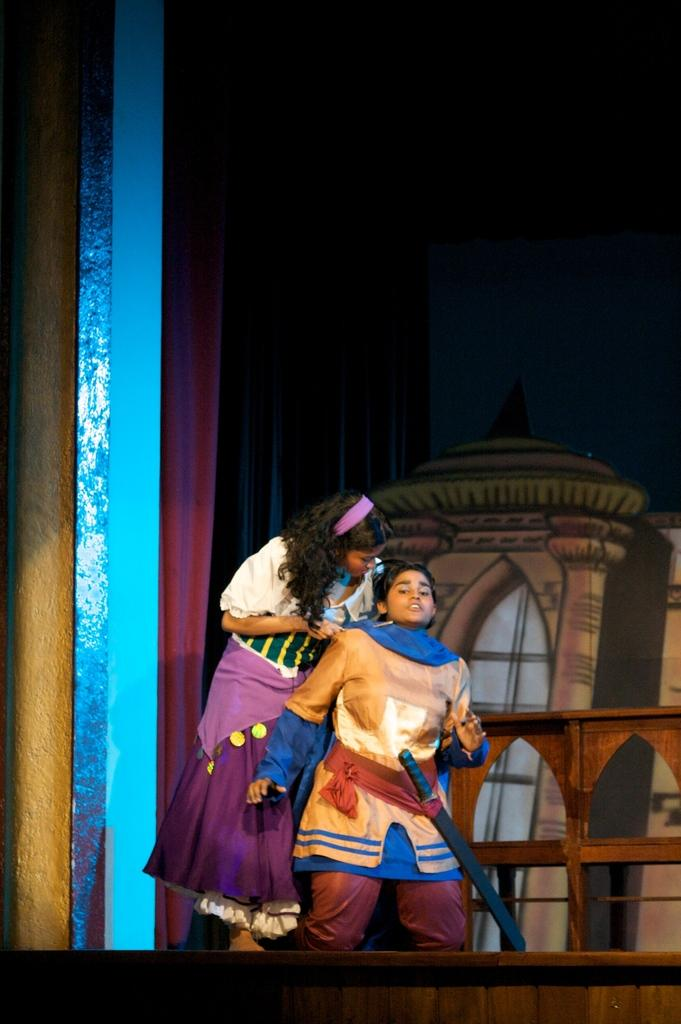Who is present in the image? There is a woman in the image. What is the woman doing in the image? The woman is behind a person holding a sword. What can be seen in the background of the image? There is an image of a building painted in the background. Where is the scene taking place? The scene is taking place on a stage. What type of holiday decoration can be seen on the woman's knee in the image? There is no holiday decoration present on the woman's knee in the image. What is the size of the woman's nose in the image? The size of the woman's nose cannot be determined from the image alone. 